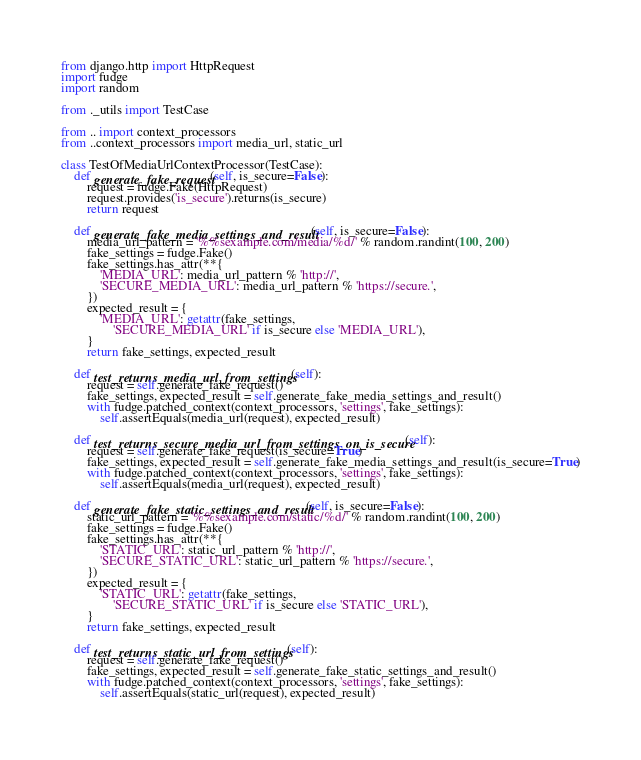<code> <loc_0><loc_0><loc_500><loc_500><_Python_>from django.http import HttpRequest
import fudge
import random

from ._utils import TestCase

from .. import context_processors
from ..context_processors import media_url, static_url

class TestOfMediaUrlContextProcessor(TestCase):
    def generate_fake_request(self, is_secure=False):
        request = fudge.Fake(HttpRequest)
        request.provides('is_secure').returns(is_secure)
        return request

    def generate_fake_media_settings_and_result(self, is_secure=False):
        media_url_pattern = '%%sexample.com/media/%d/' % random.randint(100, 200)
        fake_settings = fudge.Fake()
        fake_settings.has_attr(**{
            'MEDIA_URL': media_url_pattern % 'http://',
            'SECURE_MEDIA_URL': media_url_pattern % 'https://secure.',
        })
        expected_result = {
            'MEDIA_URL': getattr(fake_settings,
                'SECURE_MEDIA_URL' if is_secure else 'MEDIA_URL'),
        }
        return fake_settings, expected_result

    def test_returns_media_url_from_settings(self):
        request = self.generate_fake_request()
        fake_settings, expected_result = self.generate_fake_media_settings_and_result()
        with fudge.patched_context(context_processors, 'settings', fake_settings):
            self.assertEquals(media_url(request), expected_result)

    def test_returns_secure_media_url_from_settings_on_is_secure(self):
        request = self.generate_fake_request(is_secure=True)
        fake_settings, expected_result = self.generate_fake_media_settings_and_result(is_secure=True)
        with fudge.patched_context(context_processors, 'settings', fake_settings):
            self.assertEquals(media_url(request), expected_result)

    def generate_fake_static_settings_and_result(self, is_secure=False):
        static_url_pattern = '%%sexample.com/static/%d/' % random.randint(100, 200)
        fake_settings = fudge.Fake()
        fake_settings.has_attr(**{
            'STATIC_URL': static_url_pattern % 'http://',
            'SECURE_STATIC_URL': static_url_pattern % 'https://secure.',
        })
        expected_result = {
            'STATIC_URL': getattr(fake_settings,
                'SECURE_STATIC_URL' if is_secure else 'STATIC_URL'),
        }
        return fake_settings, expected_result

    def test_returns_static_url_from_settings(self):
        request = self.generate_fake_request()
        fake_settings, expected_result = self.generate_fake_static_settings_and_result()
        with fudge.patched_context(context_processors, 'settings', fake_settings):
            self.assertEquals(static_url(request), expected_result)
</code> 